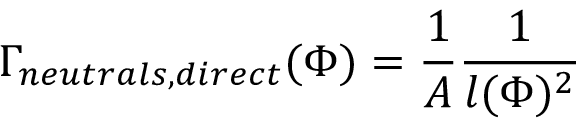<formula> <loc_0><loc_0><loc_500><loc_500>\Gamma _ { n e u t r a l s , d i r e c t } ( \Phi ) = \frac { 1 } { A } \frac { 1 } { l ( \Phi ) ^ { 2 } }</formula> 